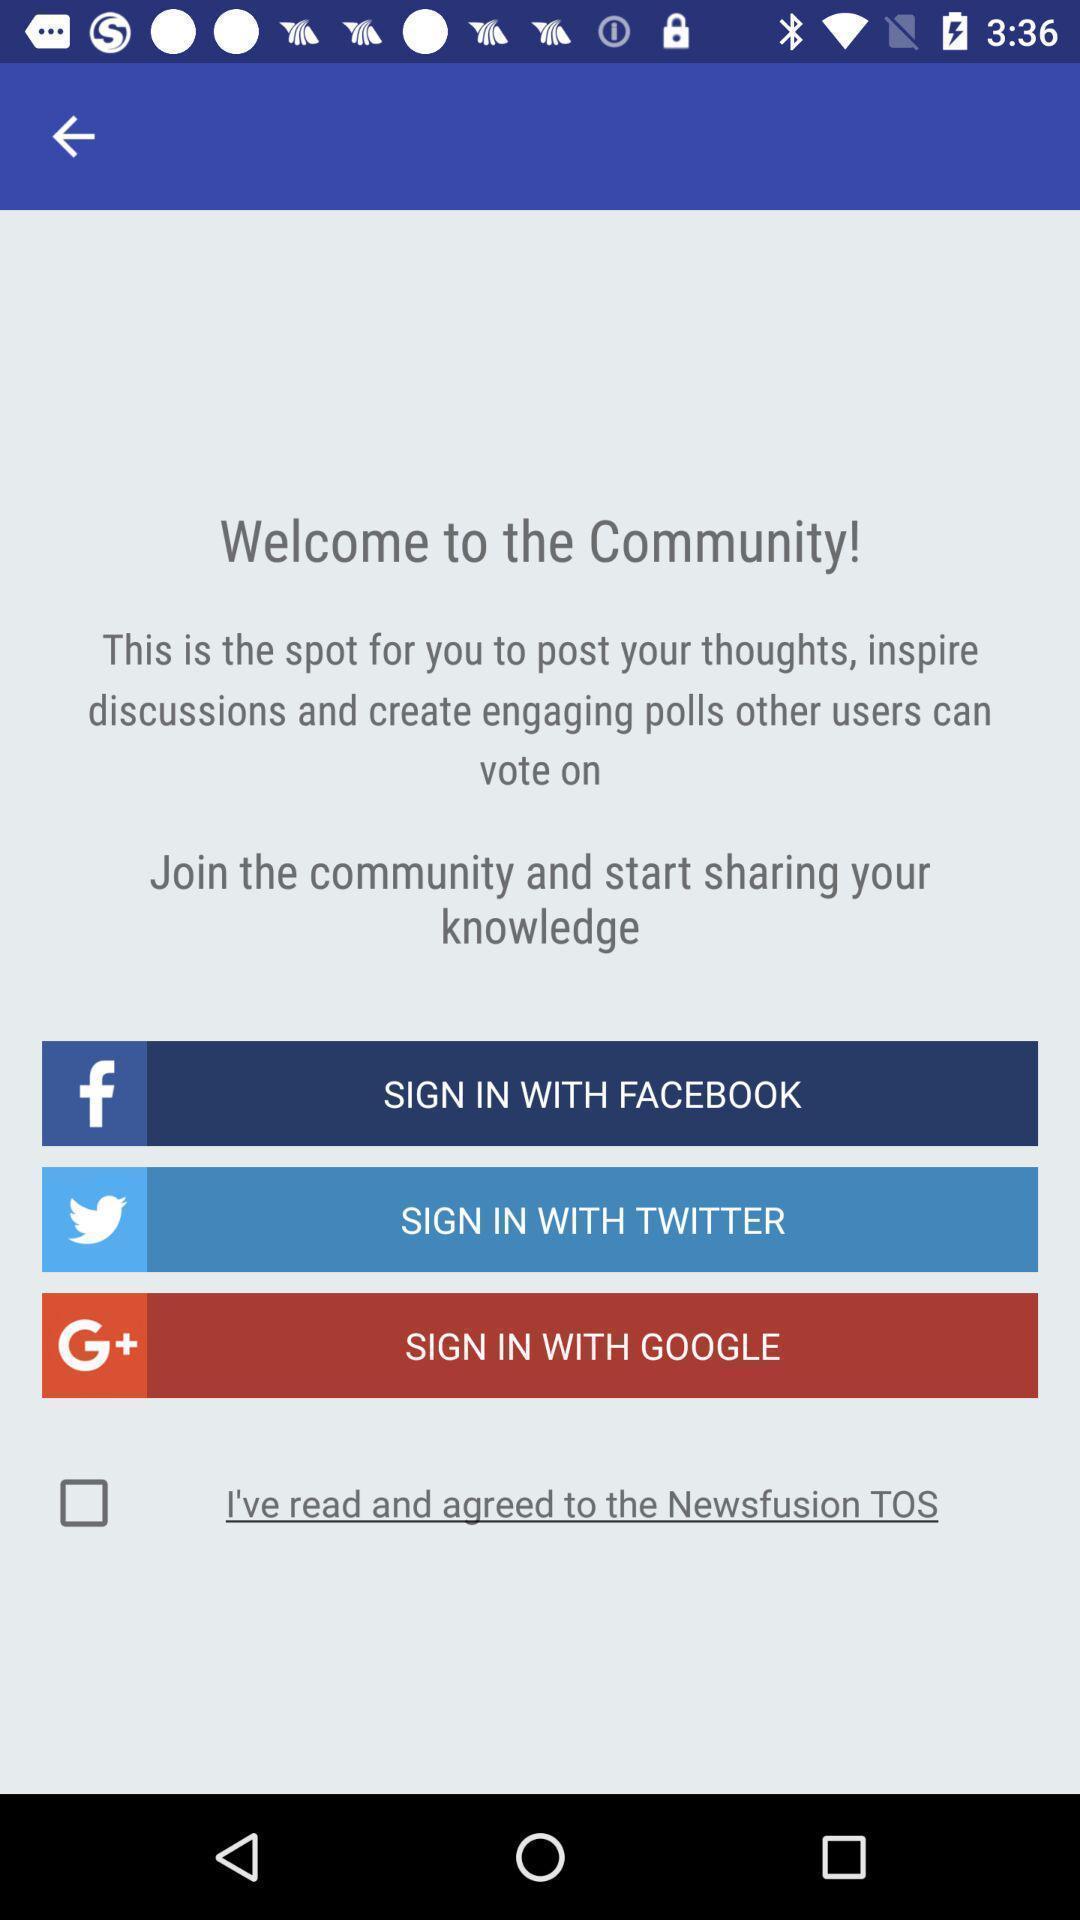Give me a summary of this screen capture. Welcome page. 